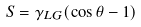Convert formula to latex. <formula><loc_0><loc_0><loc_500><loc_500>S = \gamma _ { L G } ( \cos \theta - 1 )</formula> 